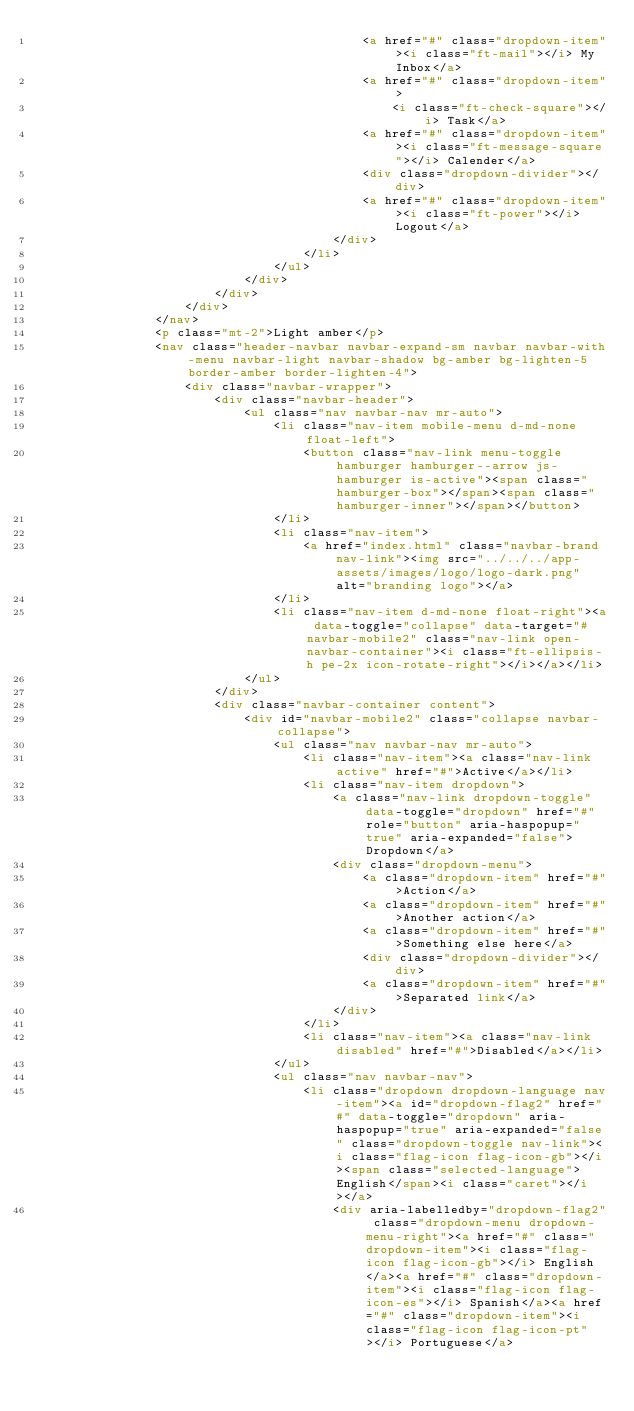<code> <loc_0><loc_0><loc_500><loc_500><_HTML_>                                            <a href="#" class="dropdown-item"><i class="ft-mail"></i> My Inbox</a>
                                            <a href="#" class="dropdown-item">
                                                <i class="ft-check-square"></i> Task</a>
                                            <a href="#" class="dropdown-item"><i class="ft-message-square"></i> Calender</a>
                                            <div class="dropdown-divider"></div>
                                            <a href="#" class="dropdown-item"><i class="ft-power"></i> Logout</a>
                                        </div>
                                    </li>
                                </ul>
                            </div>
                        </div>
                    </div>
                </nav>
                <p class="mt-2">Light amber</p>
                <nav class="header-navbar navbar-expand-sm navbar navbar-with-menu navbar-light navbar-shadow bg-amber bg-lighten-5 border-amber border-lighten-4">
                    <div class="navbar-wrapper">
                        <div class="navbar-header">
                            <ul class="nav navbar-nav mr-auto">
                                <li class="nav-item mobile-menu d-md-none float-left">
                                    <button class="nav-link menu-toggle hamburger hamburger--arrow js-hamburger is-active"><span class="hamburger-box"></span><span class="hamburger-inner"></span></button>
                                </li>
                                <li class="nav-item">
                                    <a href="index.html" class="navbar-brand nav-link"><img src="../../../app-assets/images/logo/logo-dark.png" alt="branding logo"></a>
                                </li>
                                <li class="nav-item d-md-none float-right"><a data-toggle="collapse" data-target="#navbar-mobile2" class="nav-link open-navbar-container"><i class="ft-ellipsis-h pe-2x icon-rotate-right"></i></a></li>
                            </ul>
                        </div>
                        <div class="navbar-container content">
                            <div id="navbar-mobile2" class="collapse navbar-collapse">
                                <ul class="nav navbar-nav mr-auto">
                                    <li class="nav-item"><a class="nav-link active" href="#">Active</a></li>
                                    <li class="nav-item dropdown">
                                        <a class="nav-link dropdown-toggle" data-toggle="dropdown" href="#" role="button" aria-haspopup="true" aria-expanded="false">Dropdown</a>
                                        <div class="dropdown-menu">
                                            <a class="dropdown-item" href="#">Action</a>
                                            <a class="dropdown-item" href="#">Another action</a>
                                            <a class="dropdown-item" href="#">Something else here</a>
                                            <div class="dropdown-divider"></div>
                                            <a class="dropdown-item" href="#">Separated link</a>
                                        </div>
                                    </li>
                                    <li class="nav-item"><a class="nav-link disabled" href="#">Disabled</a></li>
                                </ul>
                                <ul class="nav navbar-nav">
                                    <li class="dropdown dropdown-language nav-item"><a id="dropdown-flag2" href="#" data-toggle="dropdown" aria-haspopup="true" aria-expanded="false" class="dropdown-toggle nav-link"><i class="flag-icon flag-icon-gb"></i><span class="selected-language">English</span><i class="caret"></i></a>
                                        <div aria-labelledby="dropdown-flag2" class="dropdown-menu dropdown-menu-right"><a href="#" class="dropdown-item"><i class="flag-icon flag-icon-gb"></i> English</a><a href="#" class="dropdown-item"><i class="flag-icon flag-icon-es"></i> Spanish</a><a href="#" class="dropdown-item"><i class="flag-icon flag-icon-pt"></i> Portuguese</a></code> 